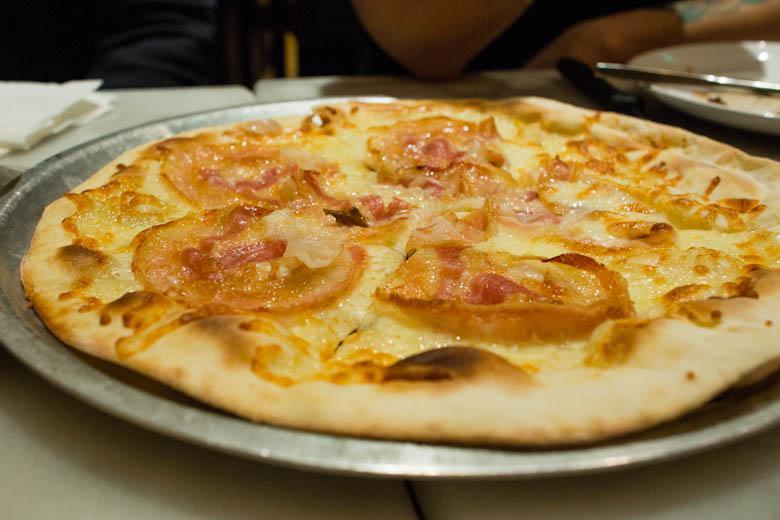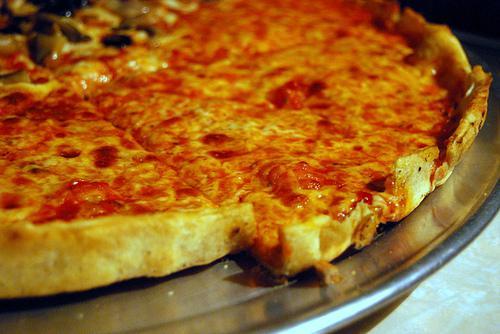The first image is the image on the left, the second image is the image on the right. Analyze the images presented: Is the assertion "Each image contains one round pizza that is not in a box and does not have any slices missing." valid? Answer yes or no. Yes. The first image is the image on the left, the second image is the image on the right. Given the left and right images, does the statement "The left and right image contains the same number of  uneaten pizzas." hold true? Answer yes or no. Yes. 